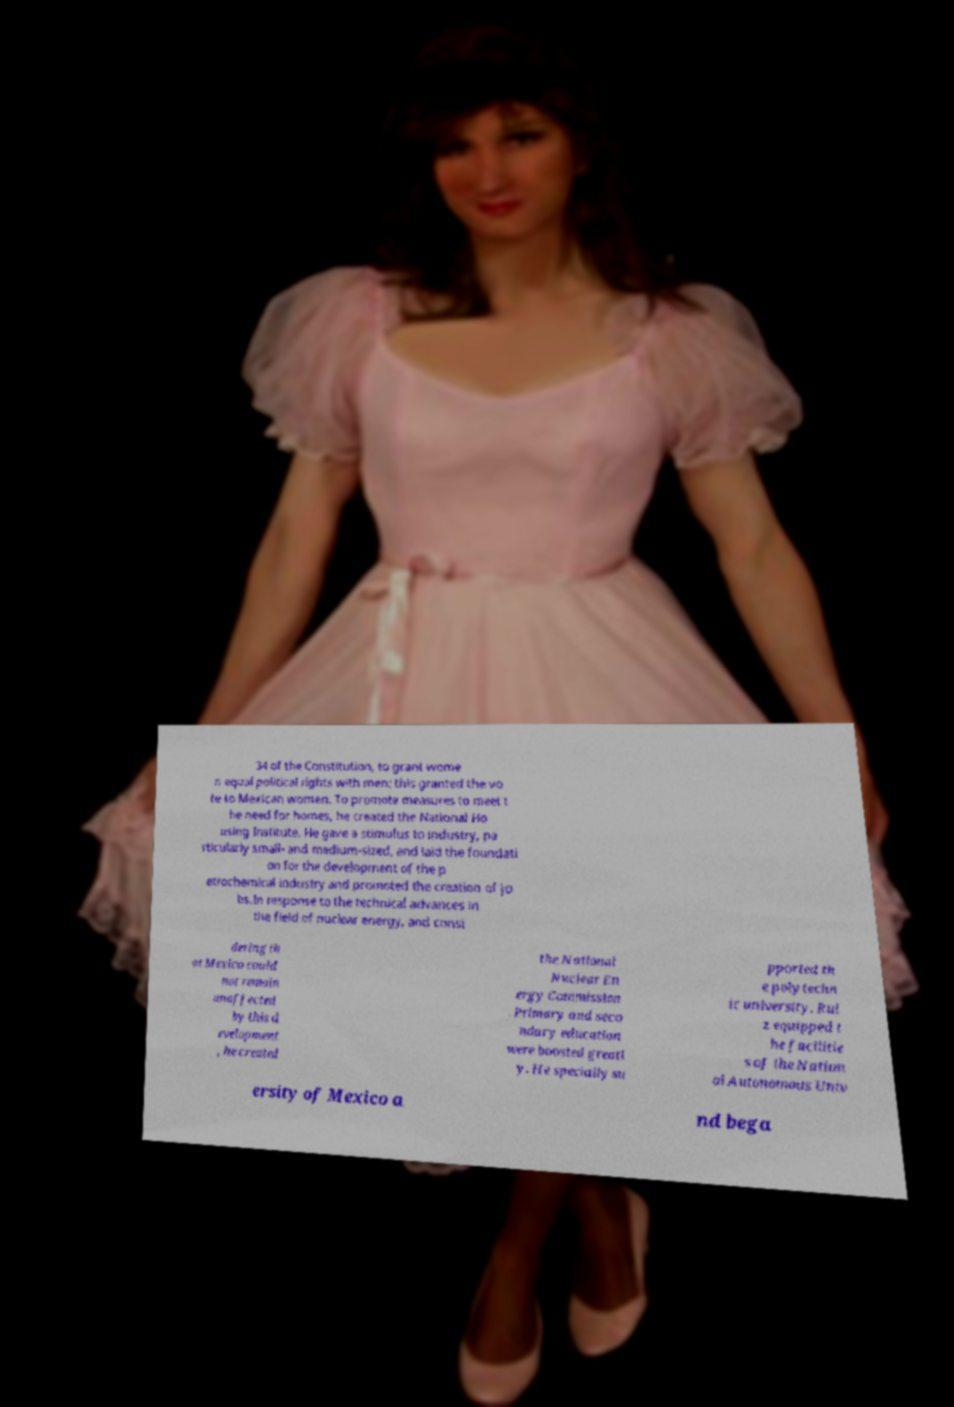There's text embedded in this image that I need extracted. Can you transcribe it verbatim? 34 of the Constitution, to grant wome n equal political rights with men; this granted the vo te to Mexican women. To promote measures to meet t he need for homes, he created the National Ho using Institute. He gave a stimulus to industry, pa rticularly small- and medium-sized, and laid the foundati on for the development of the p etrochemical industry and promoted the creation of jo bs.In response to the technical advances in the field of nuclear energy, and consi dering th at Mexico could not remain unaffected by this d evelopment , he created the National Nuclear En ergy Commission . Primary and seco ndary education were boosted greatl y. He specially su pported th e polytechn ic university. Rui z equipped t he facilitie s of the Nation al Autonomous Univ ersity of Mexico a nd bega 